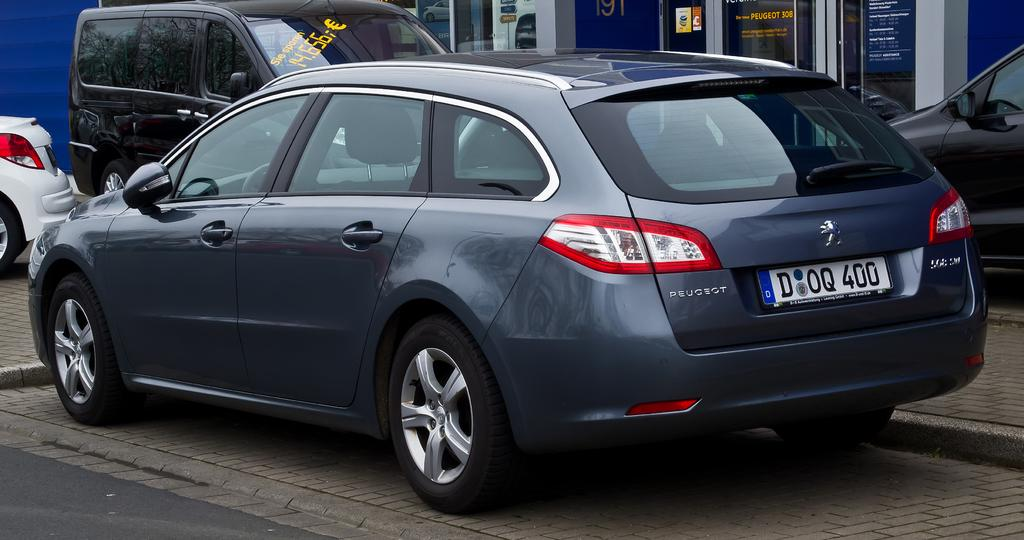What type of vehicles can be seen on the cobblestone path in the image? There are vehicles on the cobblestone path in the image. Where is the road located in the image? The road is in the left bottom of the image. What can be seen in the background of the image? There are buildings in the background of the image. What type of sack is being used in the meeting in the image? There is no meeting or sack present in the image. How many bits are visible in the image? There are no bits visible in the image. 